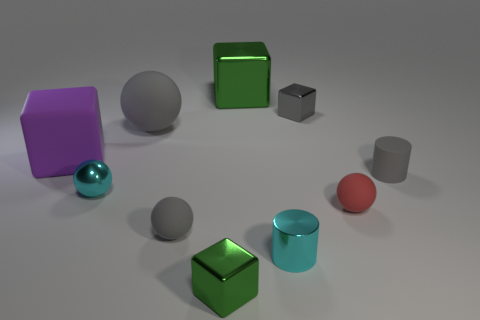Subtract 1 spheres. How many spheres are left? 3 Subtract all cubes. How many objects are left? 6 Add 9 tiny blue shiny cubes. How many tiny blue shiny cubes exist? 9 Subtract 1 cyan cylinders. How many objects are left? 9 Subtract all small yellow rubber things. Subtract all tiny cubes. How many objects are left? 8 Add 1 big gray spheres. How many big gray spheres are left? 2 